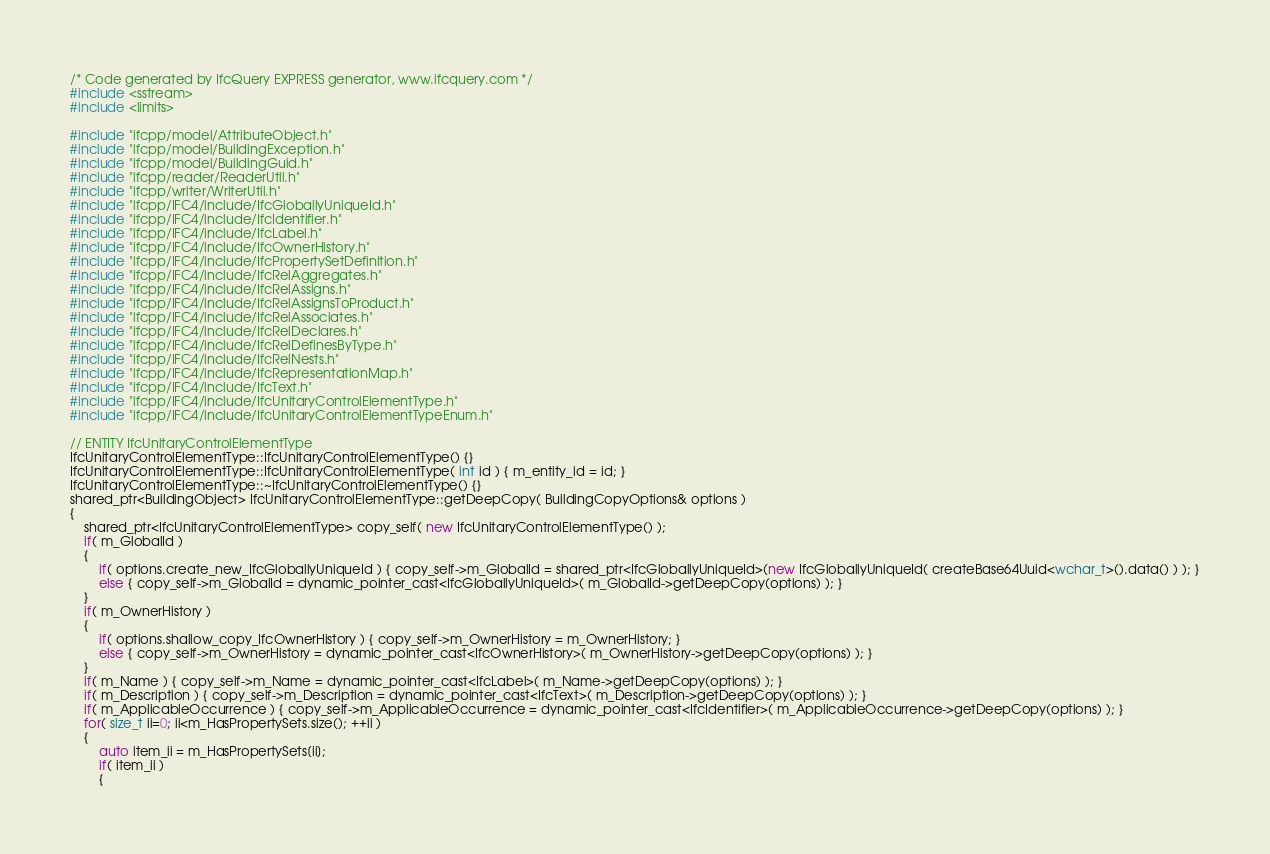Convert code to text. <code><loc_0><loc_0><loc_500><loc_500><_C++_>/* Code generated by IfcQuery EXPRESS generator, www.ifcquery.com */
#include <sstream>
#include <limits>

#include "ifcpp/model/AttributeObject.h"
#include "ifcpp/model/BuildingException.h"
#include "ifcpp/model/BuildingGuid.h"
#include "ifcpp/reader/ReaderUtil.h"
#include "ifcpp/writer/WriterUtil.h"
#include "ifcpp/IFC4/include/IfcGloballyUniqueId.h"
#include "ifcpp/IFC4/include/IfcIdentifier.h"
#include "ifcpp/IFC4/include/IfcLabel.h"
#include "ifcpp/IFC4/include/IfcOwnerHistory.h"
#include "ifcpp/IFC4/include/IfcPropertySetDefinition.h"
#include "ifcpp/IFC4/include/IfcRelAggregates.h"
#include "ifcpp/IFC4/include/IfcRelAssigns.h"
#include "ifcpp/IFC4/include/IfcRelAssignsToProduct.h"
#include "ifcpp/IFC4/include/IfcRelAssociates.h"
#include "ifcpp/IFC4/include/IfcRelDeclares.h"
#include "ifcpp/IFC4/include/IfcRelDefinesByType.h"
#include "ifcpp/IFC4/include/IfcRelNests.h"
#include "ifcpp/IFC4/include/IfcRepresentationMap.h"
#include "ifcpp/IFC4/include/IfcText.h"
#include "ifcpp/IFC4/include/IfcUnitaryControlElementType.h"
#include "ifcpp/IFC4/include/IfcUnitaryControlElementTypeEnum.h"

// ENTITY IfcUnitaryControlElementType 
IfcUnitaryControlElementType::IfcUnitaryControlElementType() {}
IfcUnitaryControlElementType::IfcUnitaryControlElementType( int id ) { m_entity_id = id; }
IfcUnitaryControlElementType::~IfcUnitaryControlElementType() {}
shared_ptr<BuildingObject> IfcUnitaryControlElementType::getDeepCopy( BuildingCopyOptions& options )
{
	shared_ptr<IfcUnitaryControlElementType> copy_self( new IfcUnitaryControlElementType() );
	if( m_GlobalId )
	{
		if( options.create_new_IfcGloballyUniqueId ) { copy_self->m_GlobalId = shared_ptr<IfcGloballyUniqueId>(new IfcGloballyUniqueId( createBase64Uuid<wchar_t>().data() ) ); }
		else { copy_self->m_GlobalId = dynamic_pointer_cast<IfcGloballyUniqueId>( m_GlobalId->getDeepCopy(options) ); }
	}
	if( m_OwnerHistory )
	{
		if( options.shallow_copy_IfcOwnerHistory ) { copy_self->m_OwnerHistory = m_OwnerHistory; }
		else { copy_self->m_OwnerHistory = dynamic_pointer_cast<IfcOwnerHistory>( m_OwnerHistory->getDeepCopy(options) ); }
	}
	if( m_Name ) { copy_self->m_Name = dynamic_pointer_cast<IfcLabel>( m_Name->getDeepCopy(options) ); }
	if( m_Description ) { copy_self->m_Description = dynamic_pointer_cast<IfcText>( m_Description->getDeepCopy(options) ); }
	if( m_ApplicableOccurrence ) { copy_self->m_ApplicableOccurrence = dynamic_pointer_cast<IfcIdentifier>( m_ApplicableOccurrence->getDeepCopy(options) ); }
	for( size_t ii=0; ii<m_HasPropertySets.size(); ++ii )
	{
		auto item_ii = m_HasPropertySets[ii];
		if( item_ii )
		{</code> 